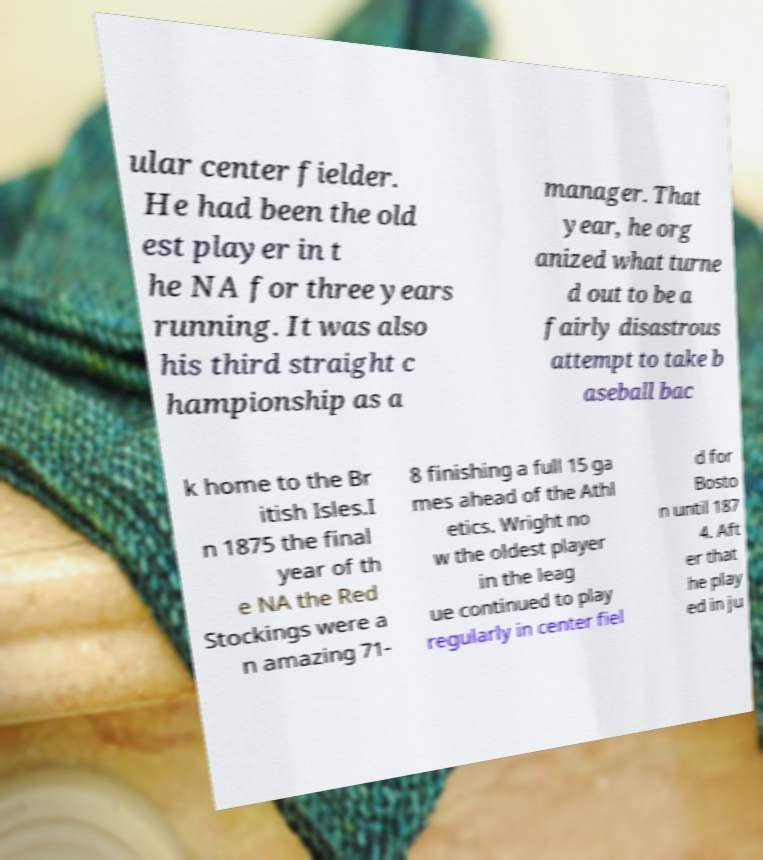What messages or text are displayed in this image? I need them in a readable, typed format. ular center fielder. He had been the old est player in t he NA for three years running. It was also his third straight c hampionship as a manager. That year, he org anized what turne d out to be a fairly disastrous attempt to take b aseball bac k home to the Br itish Isles.I n 1875 the final year of th e NA the Red Stockings were a n amazing 71- 8 finishing a full 15 ga mes ahead of the Athl etics. Wright no w the oldest player in the leag ue continued to play regularly in center fiel d for Bosto n until 187 4. Aft er that he play ed in ju 